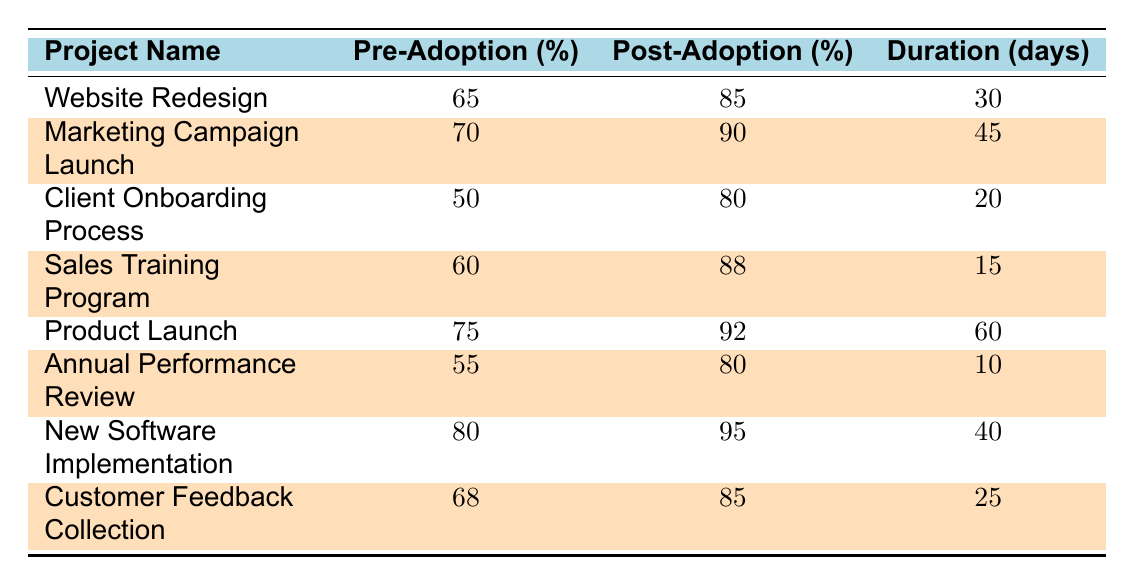What is the highest post-adoption completion rate among the projects? The highest post-adoption completion rate is found by looking at the values in the "Post-Adoption (%)" column. The highest value is 95% for the "New Software Implementation" project.
Answer: 95% Which project had the lowest pre-adoption completion rate? To find the lowest pre-adoption completion rate, we check the "Pre-Adoption (%)" column for the minimum value. The lowest value is 50% for the "Client Onboarding Process."
Answer: 50% What is the average post-adoption completion rate across all projects? To calculate the average post-adoption completion rate, we first add all the post-adoption rates: 85 + 90 + 80 + 88 + 92 + 80 + 95 + 85 = 800. There are 8 projects, so the average is 800 / 8 = 100.
Answer: 100 Did any project have a pre-adoption completion rate above 75%? We look at the "Pre-Adoption (%)" column to see if there are values exceeding 75%. The "Product Launch" and "New Software Implementation" both have higher rates at 75% and 80%, respectively.
Answer: Yes What is the total improvement in completion rates from pre-adoption to post-adoption for the "Sales Training Program"? For this project, we subtract the pre-adoption rate (60%) from the post-adoption rate (88%): 88 - 60 = 28%. Hence, the improvement is 28%.
Answer: 28% Which project had the largest duration, and how does it relate to its pre-adoption completion rate? The largest duration is 60 days for the "Product Launch." Its pre-adoption completion rate is 75%. This indicates that this project had a longer timeframe and a relatively high pre-adoption rate.
Answer: Product Launch, 75% Calculate the difference in completion rates for the "Marketing Campaign Launch" before and after adoption. For this project, the difference is calculated by subtracting the pre-adoption rate (70%) from the post-adoption rate (90%): 90 - 70 = 20%.
Answer: 20% Is there a project that saw a completion rate increase of more than 30% after adopting Office 365? We check all the improvement rates derived from post-adoption minus pre-adoption. The "Client Onboarding Process" increased by 30% (50 to 80), which does qualify, as well as the "New Software Implementation" (80 to 95), which increased by 15%. Therefore, only the latter qualifies.
Answer: Yes 